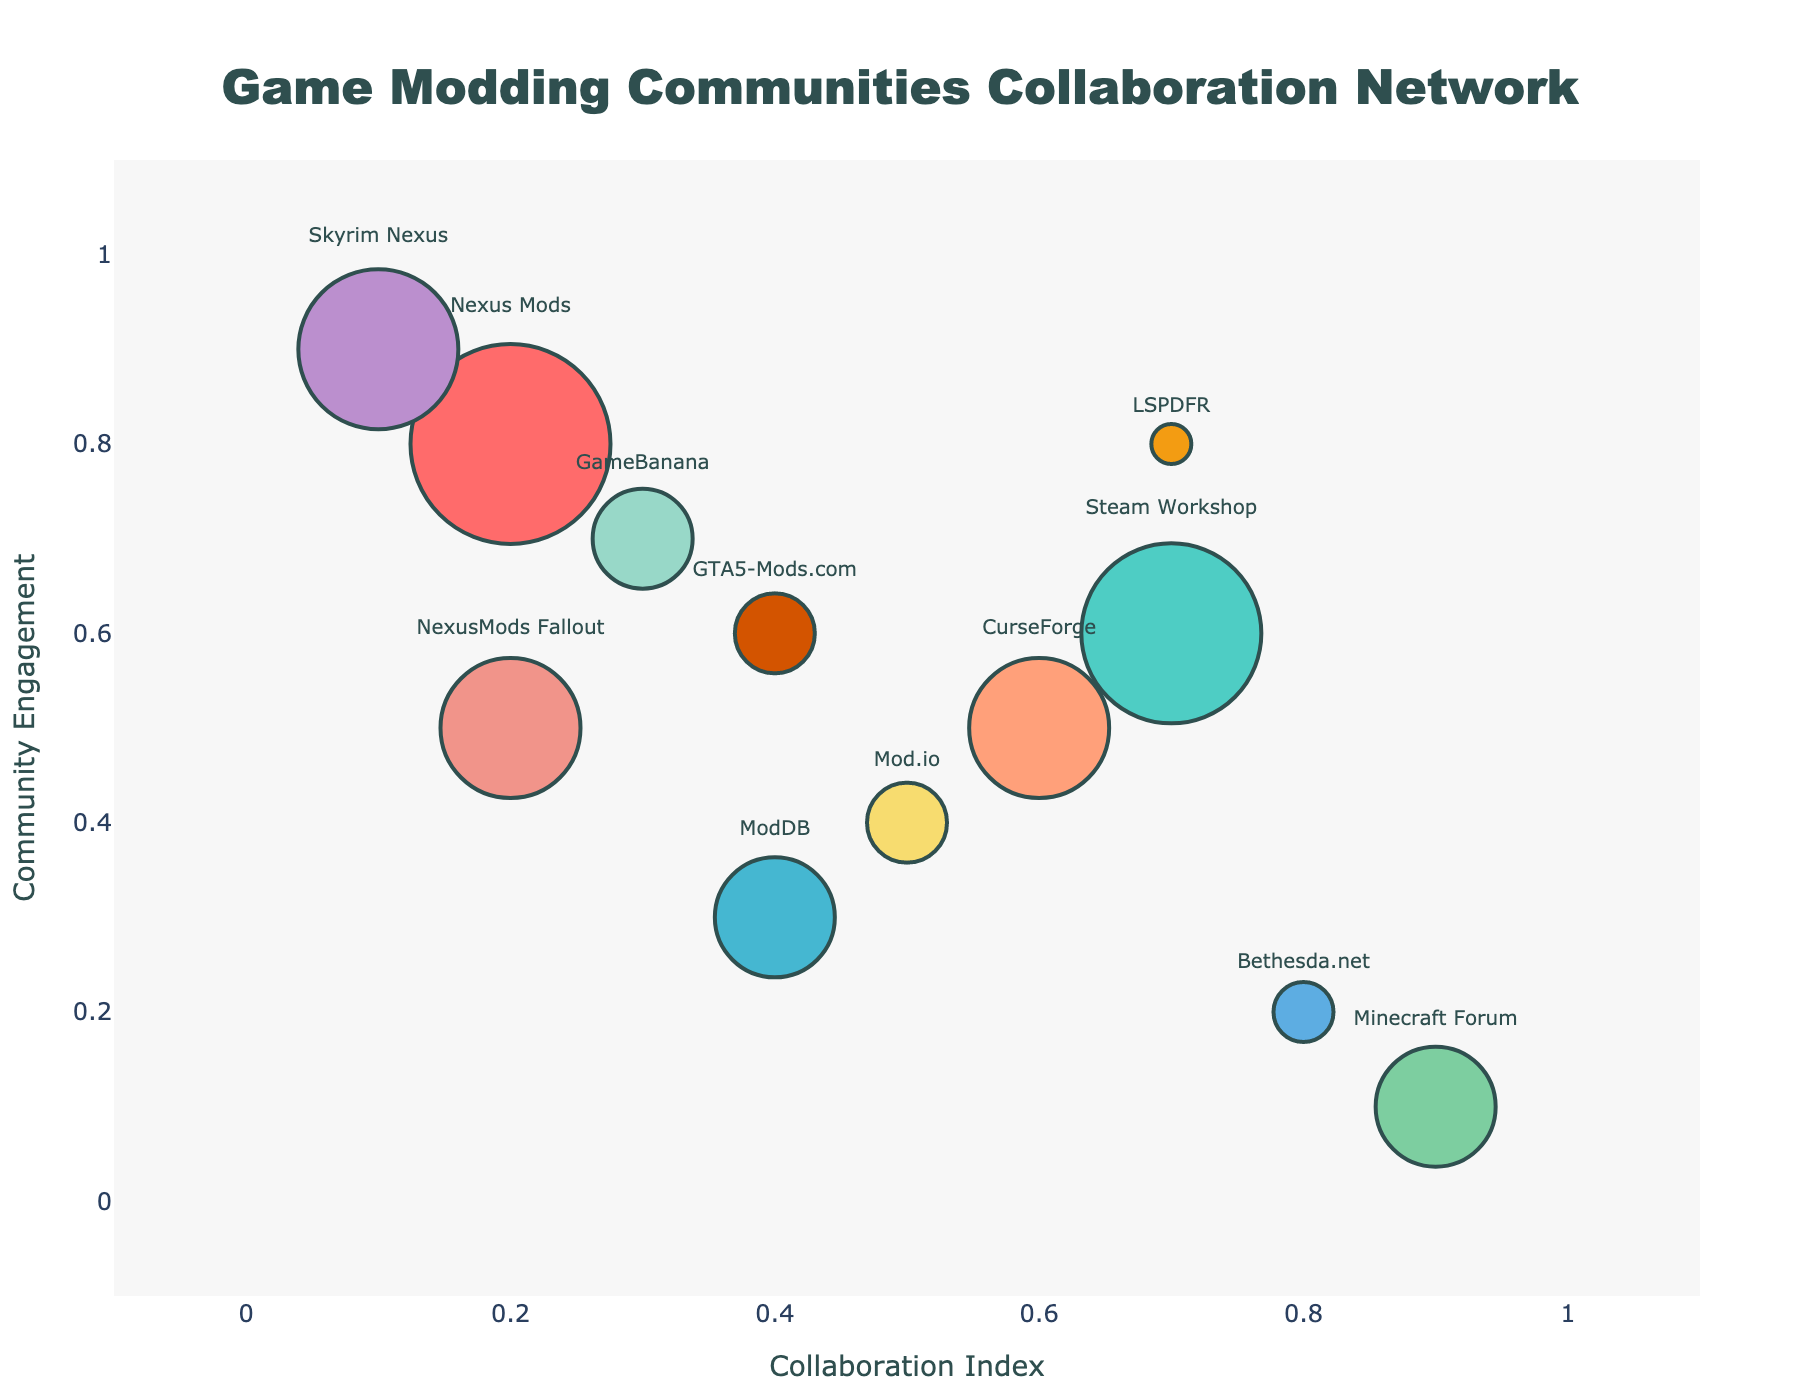What is the title of the subplot? The title is visually centered at the top of the subplot and is displayed in a large, bold font. It summarizes the main subject of the figure.
Answer: Game Modding Communities Collaboration Network Which community has the largest bubble? The size of each bubble indicates the number of shared projects. The largest bubble is easy to identify because it visually stands out with the greatest area.
Answer: Nexus Mods What are the x and y axes representing? The x and y axes titles are shown next to the axis lines, describing what each axis measures.
Answer: Collaboration Index and Community Engagement How many communities are displayed in the subplot? Count the number of distinct bubbles in the subplot, each representing a different community.
Answer: 12 Which community has the smallest number of shared projects? The hover text reveals the number of shared projects for each community. The smallest bubble size can also help identify this.
Answer: LSPDFR What is the relationship between Skyrim Nexus and Nexus Mods in terms of bubble size? Compare the sizes of the bubbles representing Skyrim Nexus and Nexus Mods to determine their relative number of shared projects.
Answer: Nexus Mods has a larger bubble than Skyrim Nexus How does the community engagement of Minecraft Forum compare with Bethesda.net? Look at the y-axis positions of the bubbles for Minecraft Forum and Bethesda.net. Compare their relative positions.
Answer: Minecraft Forum has higher community engagement than Bethesda.net Which communities have the same community engagement as GameBanana? Check the y-axis value for GameBanana and see which other communities share the same y-axis position.
Answer: None What is the total number of shared projects among Nexus Mods, Steam Workshop, and ModDB? Sum the shared projects values for Nexus Mods, Steam Workshop, and ModDB.
Answer: 290 Which community lies closest to the top right corner of the subplot? Identify the bubble closest to the maximum values on both the x-axis and y-axis.
Answer: LSPDFR 